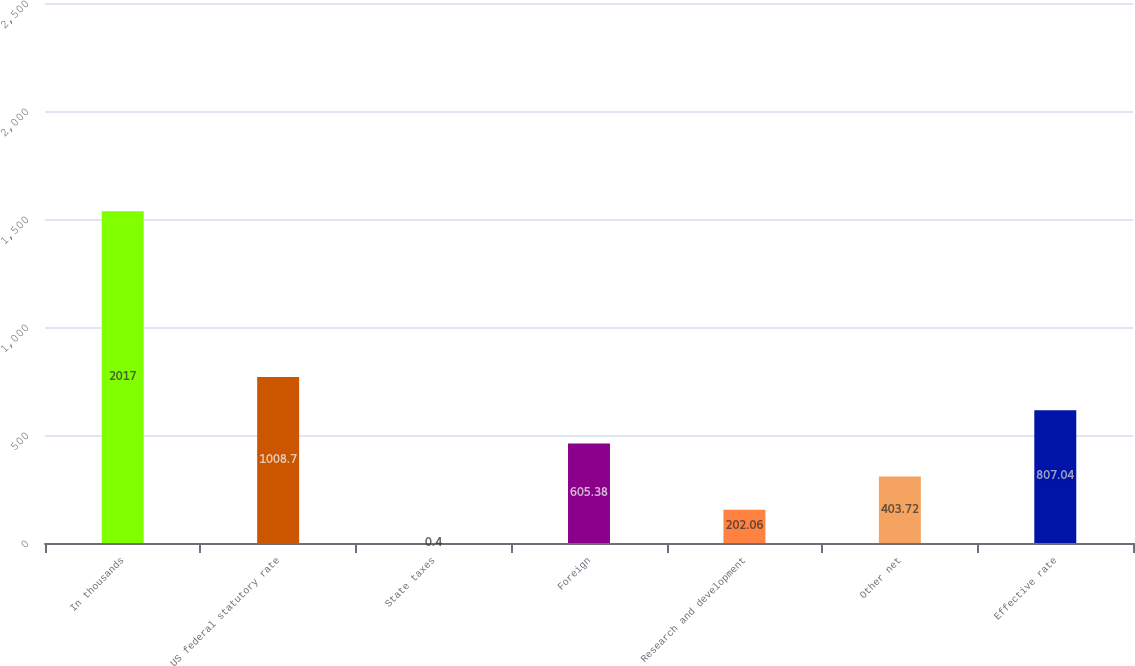<chart> <loc_0><loc_0><loc_500><loc_500><bar_chart><fcel>In thousands<fcel>US federal statutory rate<fcel>State taxes<fcel>Foreign<fcel>Research and development<fcel>Other net<fcel>Effective rate<nl><fcel>2017<fcel>1008.7<fcel>0.4<fcel>605.38<fcel>202.06<fcel>403.72<fcel>807.04<nl></chart> 